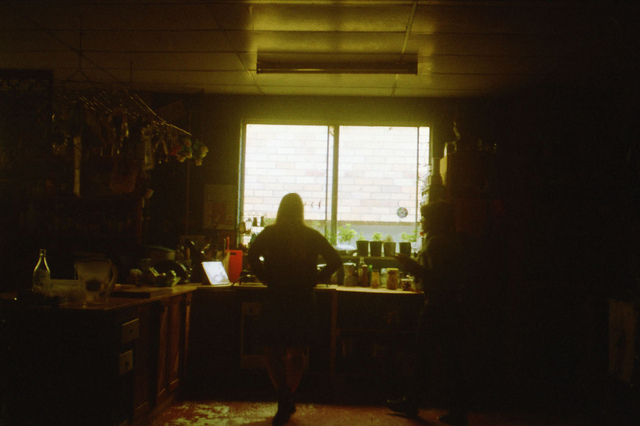What kind of items can be seen near the window in the kitchen? Near the window, there appears to be a variety of kitchen items, including jars, bottles, and possibly some herbs hanging. The natural light illuminates these items, giving the area a functional yet homely appearance. 